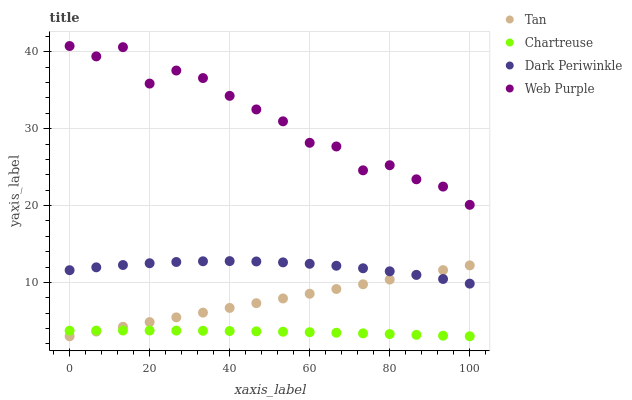Does Chartreuse have the minimum area under the curve?
Answer yes or no. Yes. Does Web Purple have the maximum area under the curve?
Answer yes or no. Yes. Does Tan have the minimum area under the curve?
Answer yes or no. No. Does Tan have the maximum area under the curve?
Answer yes or no. No. Is Tan the smoothest?
Answer yes or no. Yes. Is Web Purple the roughest?
Answer yes or no. Yes. Is Chartreuse the smoothest?
Answer yes or no. No. Is Chartreuse the roughest?
Answer yes or no. No. Does Tan have the lowest value?
Answer yes or no. Yes. Does Dark Periwinkle have the lowest value?
Answer yes or no. No. Does Web Purple have the highest value?
Answer yes or no. Yes. Does Tan have the highest value?
Answer yes or no. No. Is Dark Periwinkle less than Web Purple?
Answer yes or no. Yes. Is Web Purple greater than Tan?
Answer yes or no. Yes. Does Tan intersect Dark Periwinkle?
Answer yes or no. Yes. Is Tan less than Dark Periwinkle?
Answer yes or no. No. Is Tan greater than Dark Periwinkle?
Answer yes or no. No. Does Dark Periwinkle intersect Web Purple?
Answer yes or no. No. 